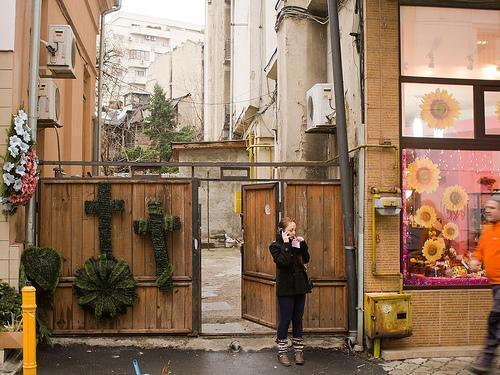How many women?
Give a very brief answer. 1. 